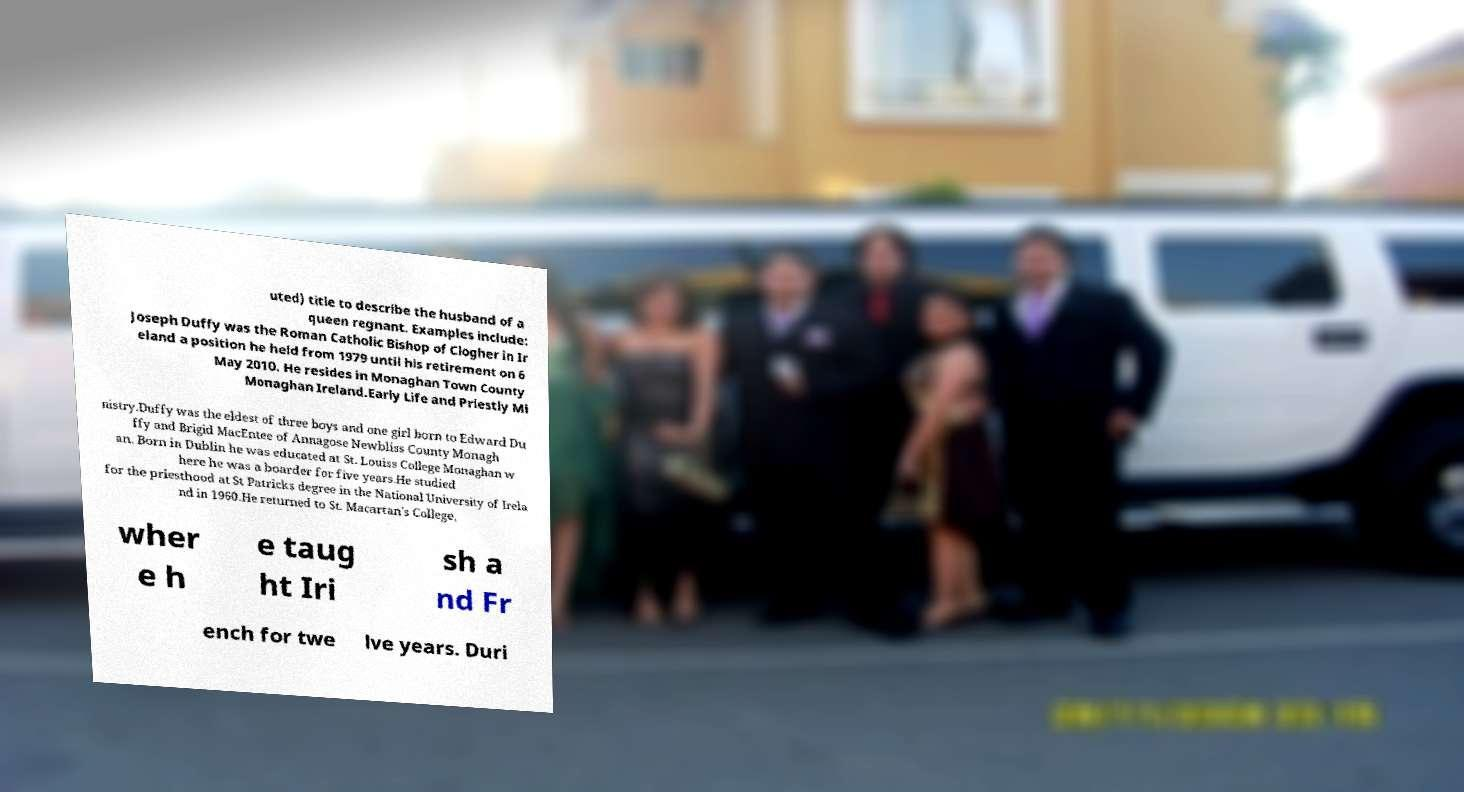Can you read and provide the text displayed in the image?This photo seems to have some interesting text. Can you extract and type it out for me? uted) title to describe the husband of a queen regnant. Examples include: Joseph Duffy was the Roman Catholic Bishop of Clogher in Ir eland a position he held from 1979 until his retirement on 6 May 2010. He resides in Monaghan Town County Monaghan Ireland.Early Life and Priestly Mi nistry.Duffy was the eldest of three boys and one girl born to Edward Du ffy and Brigid MacEntee of Annagose Newbliss County Monagh an. Born in Dublin he was educated at St. Louiss College Monaghan w here he was a boarder for five years.He studied for the priesthood at St Patricks degree in the National University of Irela nd in 1960.He returned to St. Macartan's College, wher e h e taug ht Iri sh a nd Fr ench for twe lve years. Duri 